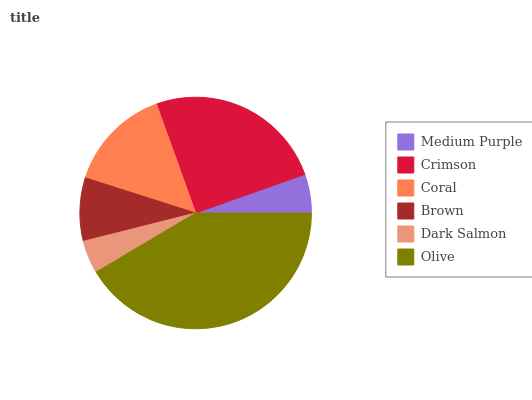Is Dark Salmon the minimum?
Answer yes or no. Yes. Is Olive the maximum?
Answer yes or no. Yes. Is Crimson the minimum?
Answer yes or no. No. Is Crimson the maximum?
Answer yes or no. No. Is Crimson greater than Medium Purple?
Answer yes or no. Yes. Is Medium Purple less than Crimson?
Answer yes or no. Yes. Is Medium Purple greater than Crimson?
Answer yes or no. No. Is Crimson less than Medium Purple?
Answer yes or no. No. Is Coral the high median?
Answer yes or no. Yes. Is Brown the low median?
Answer yes or no. Yes. Is Crimson the high median?
Answer yes or no. No. Is Crimson the low median?
Answer yes or no. No. 